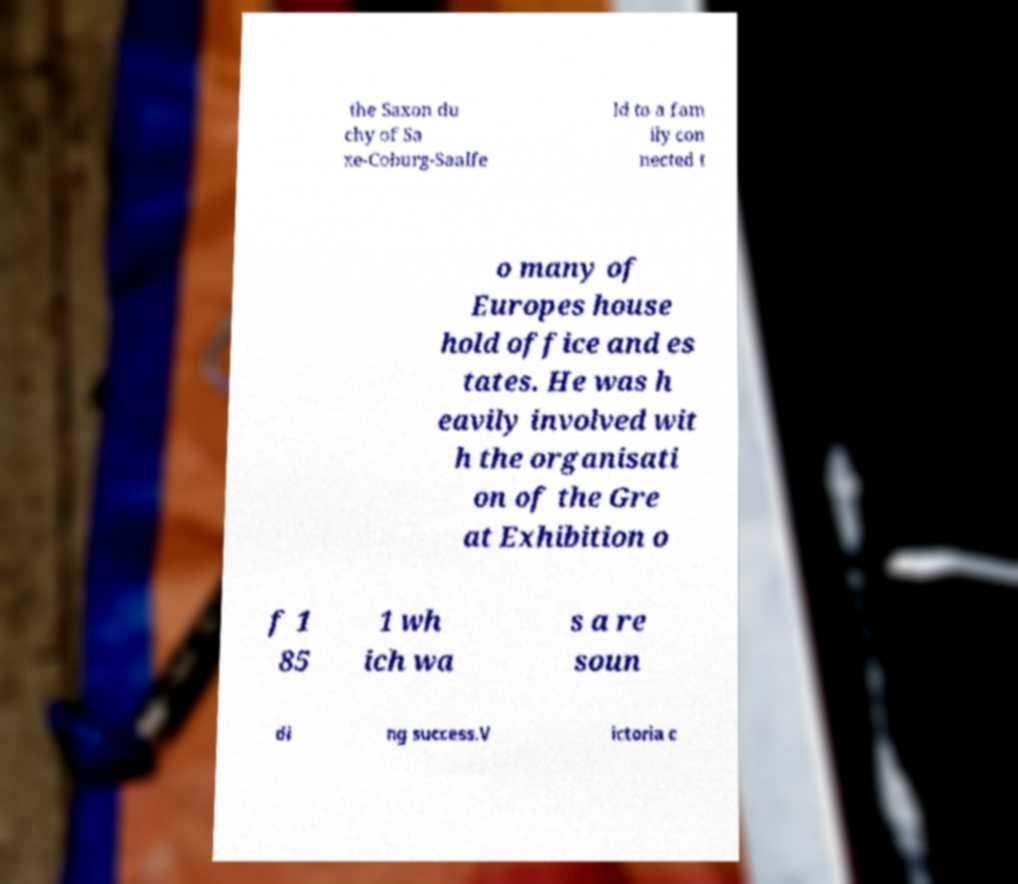What messages or text are displayed in this image? I need them in a readable, typed format. the Saxon du chy of Sa xe-Coburg-Saalfe ld to a fam ily con nected t o many of Europes house hold office and es tates. He was h eavily involved wit h the organisati on of the Gre at Exhibition o f 1 85 1 wh ich wa s a re soun di ng success.V ictoria c 